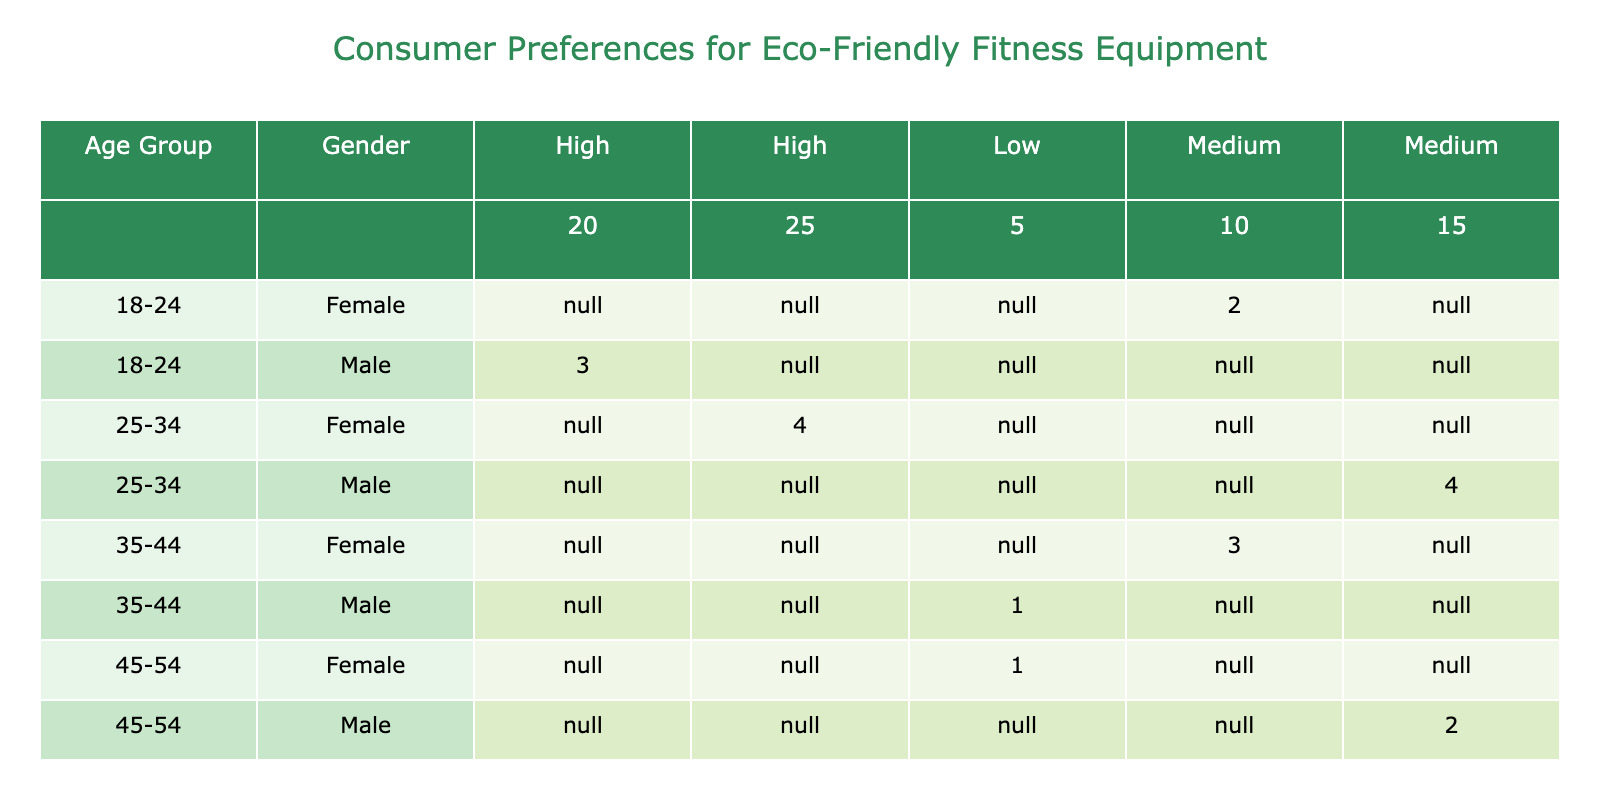What is the frequency of purchase intention for Male consumers aged 25-34 who have a Medium preference for eco-friendly materials? From the table, for the Male consumers in the age group 25-34 with a Medium preference for eco-friendly materials, the frequency of purchase intention is 4.
Answer: 4 What is the total frequency of purchase intention for females aged 18-24 and 25-34 combined? For females aged 18-24, the frequency is 2. For females aged 25-34, the frequency is 4. Adding these together gives 2 + 4 = 6.
Answer: 6 Is it true that all Male consumers aged 35-44 have a High preference for eco-friendly materials? Checking the table, the Male consumers aged 35-44 have a Low preference for eco-friendly materials, so the statement is false.
Answer: No What is the average willingness to pay more for eco-friendly products for Female consumers across all age groups? Looking at Female consumers: 10 for aged 18-24, 25 for aged 25-34, 10 for aged 35-44, 5 for aged 45-54, and 10 for aged 55+. Summing these gives 10 + 25 + 10 + 5 + 10 = 70. Since there are 5 females, the average is 70/5 = 14.
Answer: 14 What is the frequency of purchase intention for Male consumers aged 45-54 with a Medium preference for eco-friendly materials? From the table, for Male consumers in the age group 45-54 with a Medium preference for eco-friendly materials, the frequency of purchase intention is 2.
Answer: 2 What is the total willingness to pay more for eco-friendly products for all consumers in the age group 55+? For consumers aged 55+, Male has 5 and Female has 10, leading to a total of 5 + 10 = 15.
Answer: 15 Do more Females in the age group 25-34 prefer eco-friendly materials than Males in the same age group? Checking the data, 4 Females have a High preference while 4 Males have a Medium preference. Since 'High' is a stronger preference than 'Medium', the statement is true.
Answer: Yes What is the highest frequency of purchase intention recorded in the table? Observing the table, the highest frequency comes from Male consumers aged 25-34 with a Medium preference for eco-friendly materials, which is 4.
Answer: 4 